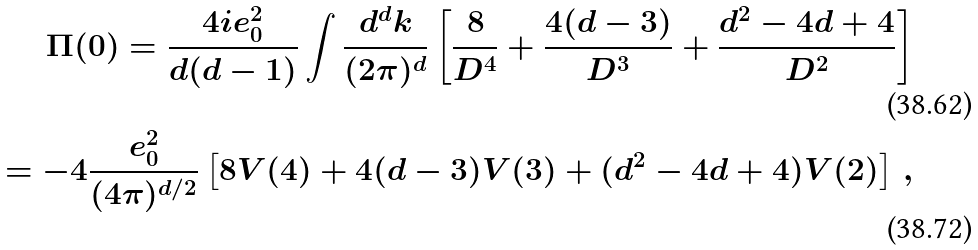Convert formula to latex. <formula><loc_0><loc_0><loc_500><loc_500>\Pi ( 0 ) = \frac { 4 i e _ { 0 } ^ { 2 } } { d ( d - 1 ) } \int \frac { d ^ { d } k } { ( 2 \pi ) ^ { d } } \left [ \frac { 8 } { D ^ { 4 } } + \frac { 4 ( d - 3 ) } { D ^ { 3 } } + \frac { d ^ { 2 } - 4 d + 4 } { D ^ { 2 } } \right ] \\ = - 4 \frac { e _ { 0 } ^ { 2 } } { ( 4 \pi ) ^ { d / 2 } } \left [ 8 V ( 4 ) + 4 ( d - 3 ) V ( 3 ) + ( d ^ { 2 } - 4 d + 4 ) V ( 2 ) \right ] \, ,</formula> 